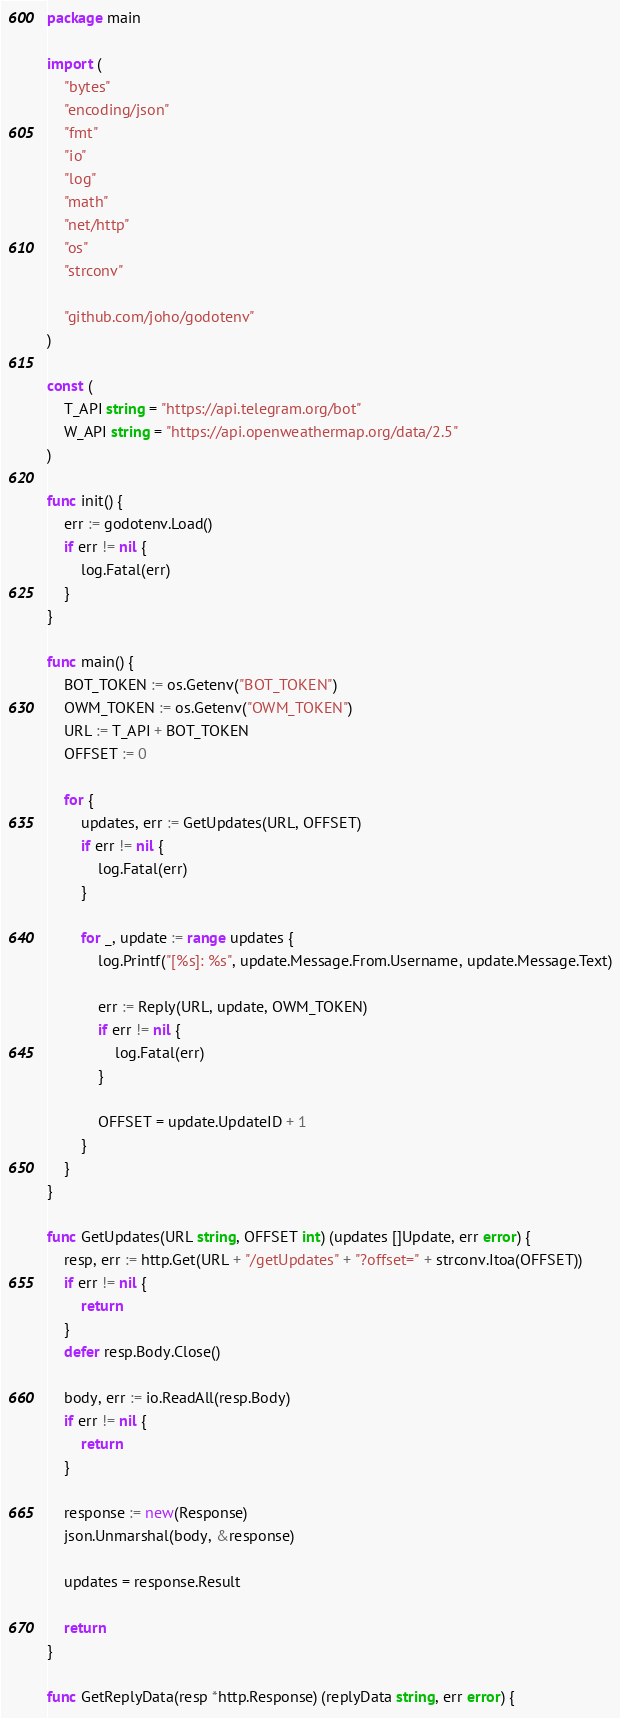<code> <loc_0><loc_0><loc_500><loc_500><_Go_>package main

import (
	"bytes"
	"encoding/json"
	"fmt"
	"io"
	"log"
	"math"
	"net/http"
	"os"
	"strconv"

	"github.com/joho/godotenv"
)

const (
	T_API string = "https://api.telegram.org/bot"
	W_API string = "https://api.openweathermap.org/data/2.5"
)

func init() {
	err := godotenv.Load()
	if err != nil {
		log.Fatal(err)
	}
}

func main() {
	BOT_TOKEN := os.Getenv("BOT_TOKEN")
	OWM_TOKEN := os.Getenv("OWM_TOKEN")
	URL := T_API + BOT_TOKEN
	OFFSET := 0

	for {
		updates, err := GetUpdates(URL, OFFSET)
		if err != nil {
			log.Fatal(err)
		}

		for _, update := range updates {
			log.Printf("[%s]: %s", update.Message.From.Username, update.Message.Text)

			err := Reply(URL, update, OWM_TOKEN)
			if err != nil {
				log.Fatal(err)
			}

			OFFSET = update.UpdateID + 1
		}
	}
}

func GetUpdates(URL string, OFFSET int) (updates []Update, err error) {
	resp, err := http.Get(URL + "/getUpdates" + "?offset=" + strconv.Itoa(OFFSET))
	if err != nil {
		return
	}
	defer resp.Body.Close()

	body, err := io.ReadAll(resp.Body)
	if err != nil {
		return
	}

	response := new(Response)
	json.Unmarshal(body, &response)

	updates = response.Result

	return
}

func GetReplyData(resp *http.Response) (replyData string, err error) {</code> 